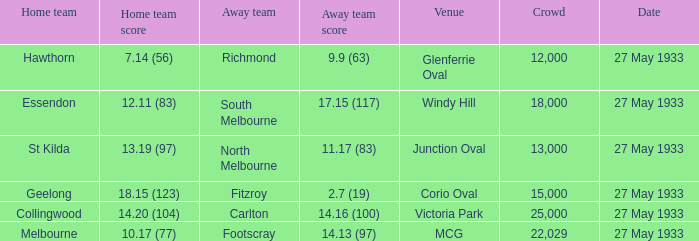In the match where the away team scored 2.7 (19), how many peopel were in the crowd? 15000.0. 